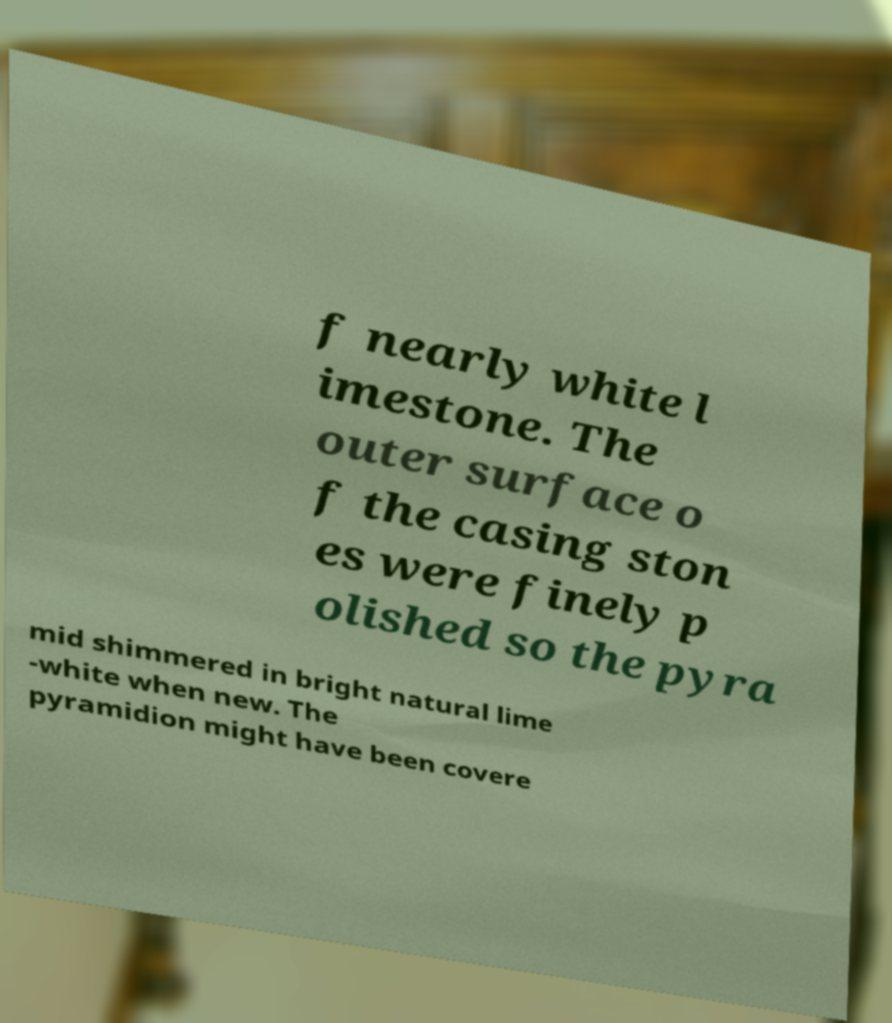For documentation purposes, I need the text within this image transcribed. Could you provide that? f nearly white l imestone. The outer surface o f the casing ston es were finely p olished so the pyra mid shimmered in bright natural lime -white when new. The pyramidion might have been covere 